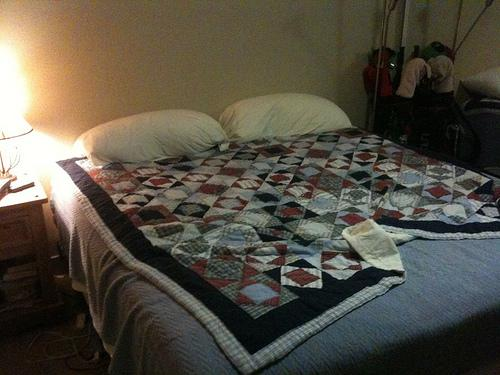Question: what is on the bed?
Choices:
A. The phone.
B. A man.
C. A woman.
D. Nothing.
Answer with the letter. Answer: D Question: where was the photo taken?
Choices:
A. In the bedroom.
B. School.
C. Work.
D. Home.
Answer with the letter. Answer: A 